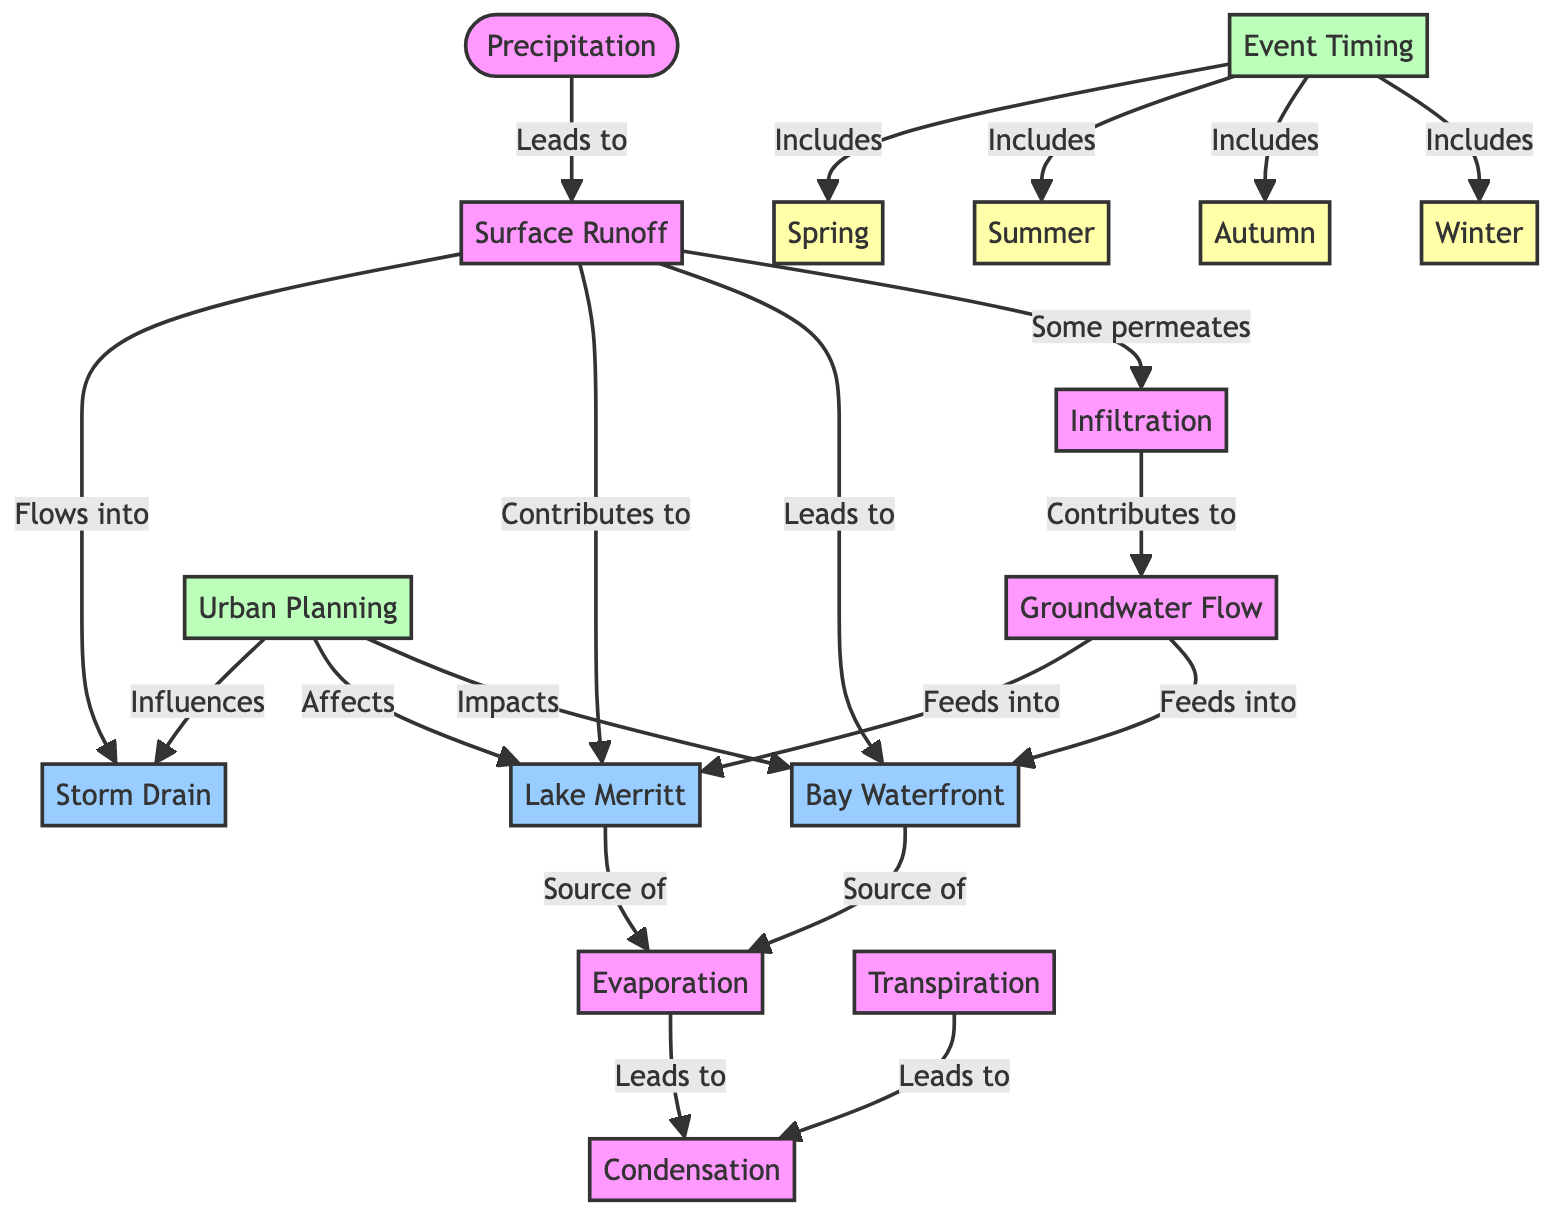What is the final destination of surface runoff? Surface runoff is depicted in the diagram as leading into the storm drain, contributing to Lake Merritt, and flowing into the Bay Waterfront. Based on the diagram, the destinations are: storm drain, Lake Merritt, and Bay Waterfront. Since the question asks for the final destinations, the three locations combined are the answer.
Answer: Storm drain, Lake Merritt, Bay Waterfront Which seasonal events are included in event timing? The diagram clearly shows that event timing includes four seasonal nodes: Spring, Summer, Autumn, and Winter. By identifying these nodes directly connected to event timing, we determine the answer.
Answer: Spring, Summer, Autumn, Winter How does urban planning influence water sources? Urban planning influences the storm drain and impacts both Lake Merritt and Bay Waterfront as shown by the arrows pointing from urban planning to these water sources. This establishes the connection and influence of urban planning on them.
Answer: Storm drain, Lake Merritt, Bay Waterfront What is created through the processes of evaporation and transpiration? The diagram indicates that both evaporation and transpiration lead to condensation. By analyzing these two processes and their direct connection to condensation, we find the outcome of these processes.
Answer: Condensation What is the relationship between infiltration and groundwater flow? The diagram illustrates that infiltration contributes to groundwater flow, which means that water from infiltration is directed into groundwater flow. This direct relationship in the flow of the diagram validates the connection.
Answer: Contributes to 